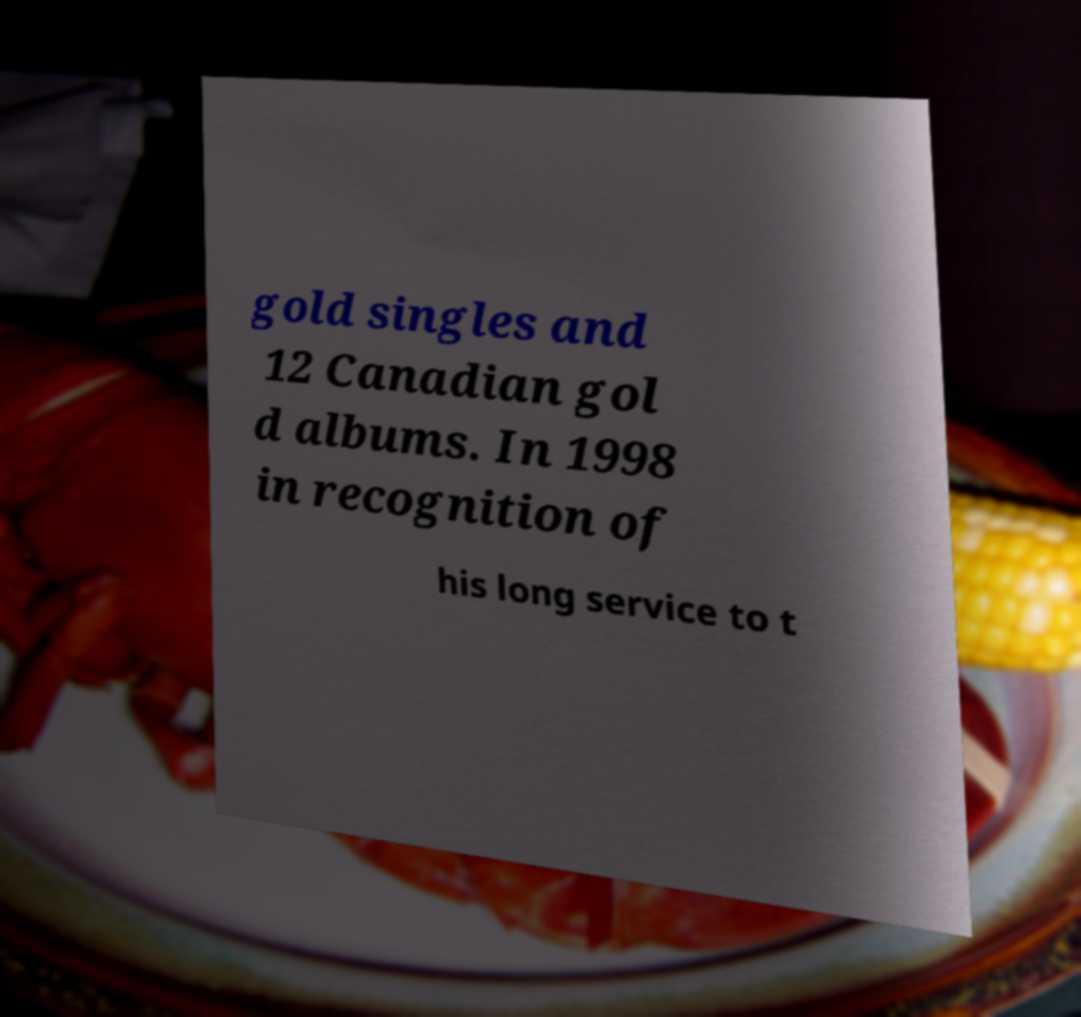For documentation purposes, I need the text within this image transcribed. Could you provide that? gold singles and 12 Canadian gol d albums. In 1998 in recognition of his long service to t 